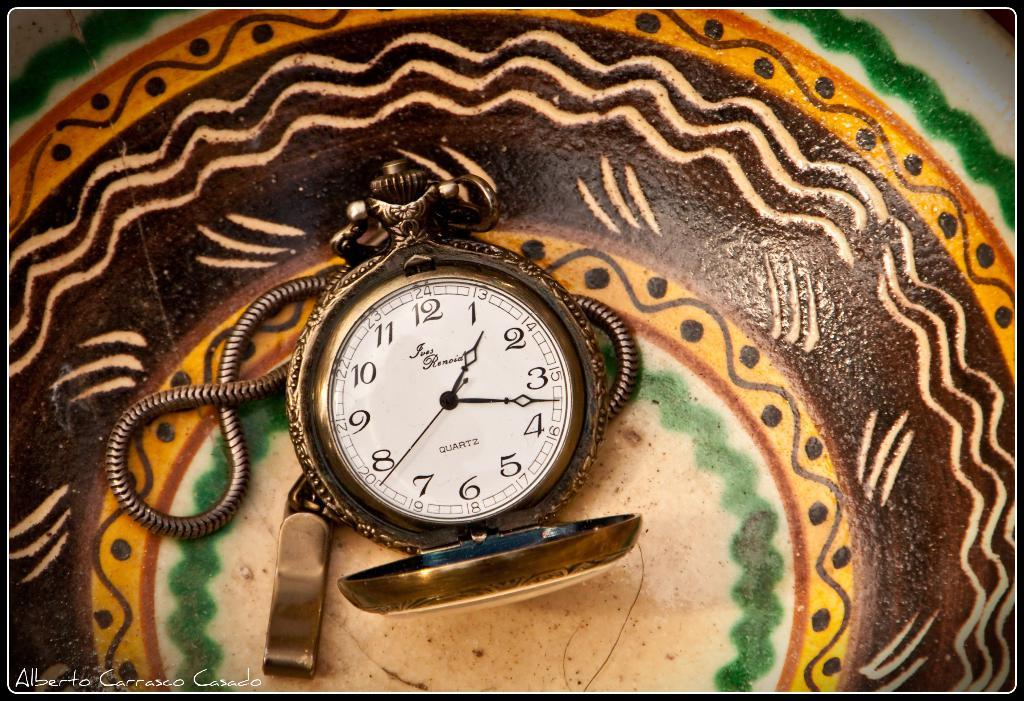<image>
Share a concise interpretation of the image provided. A watch face has the brand name Quartz on it. 